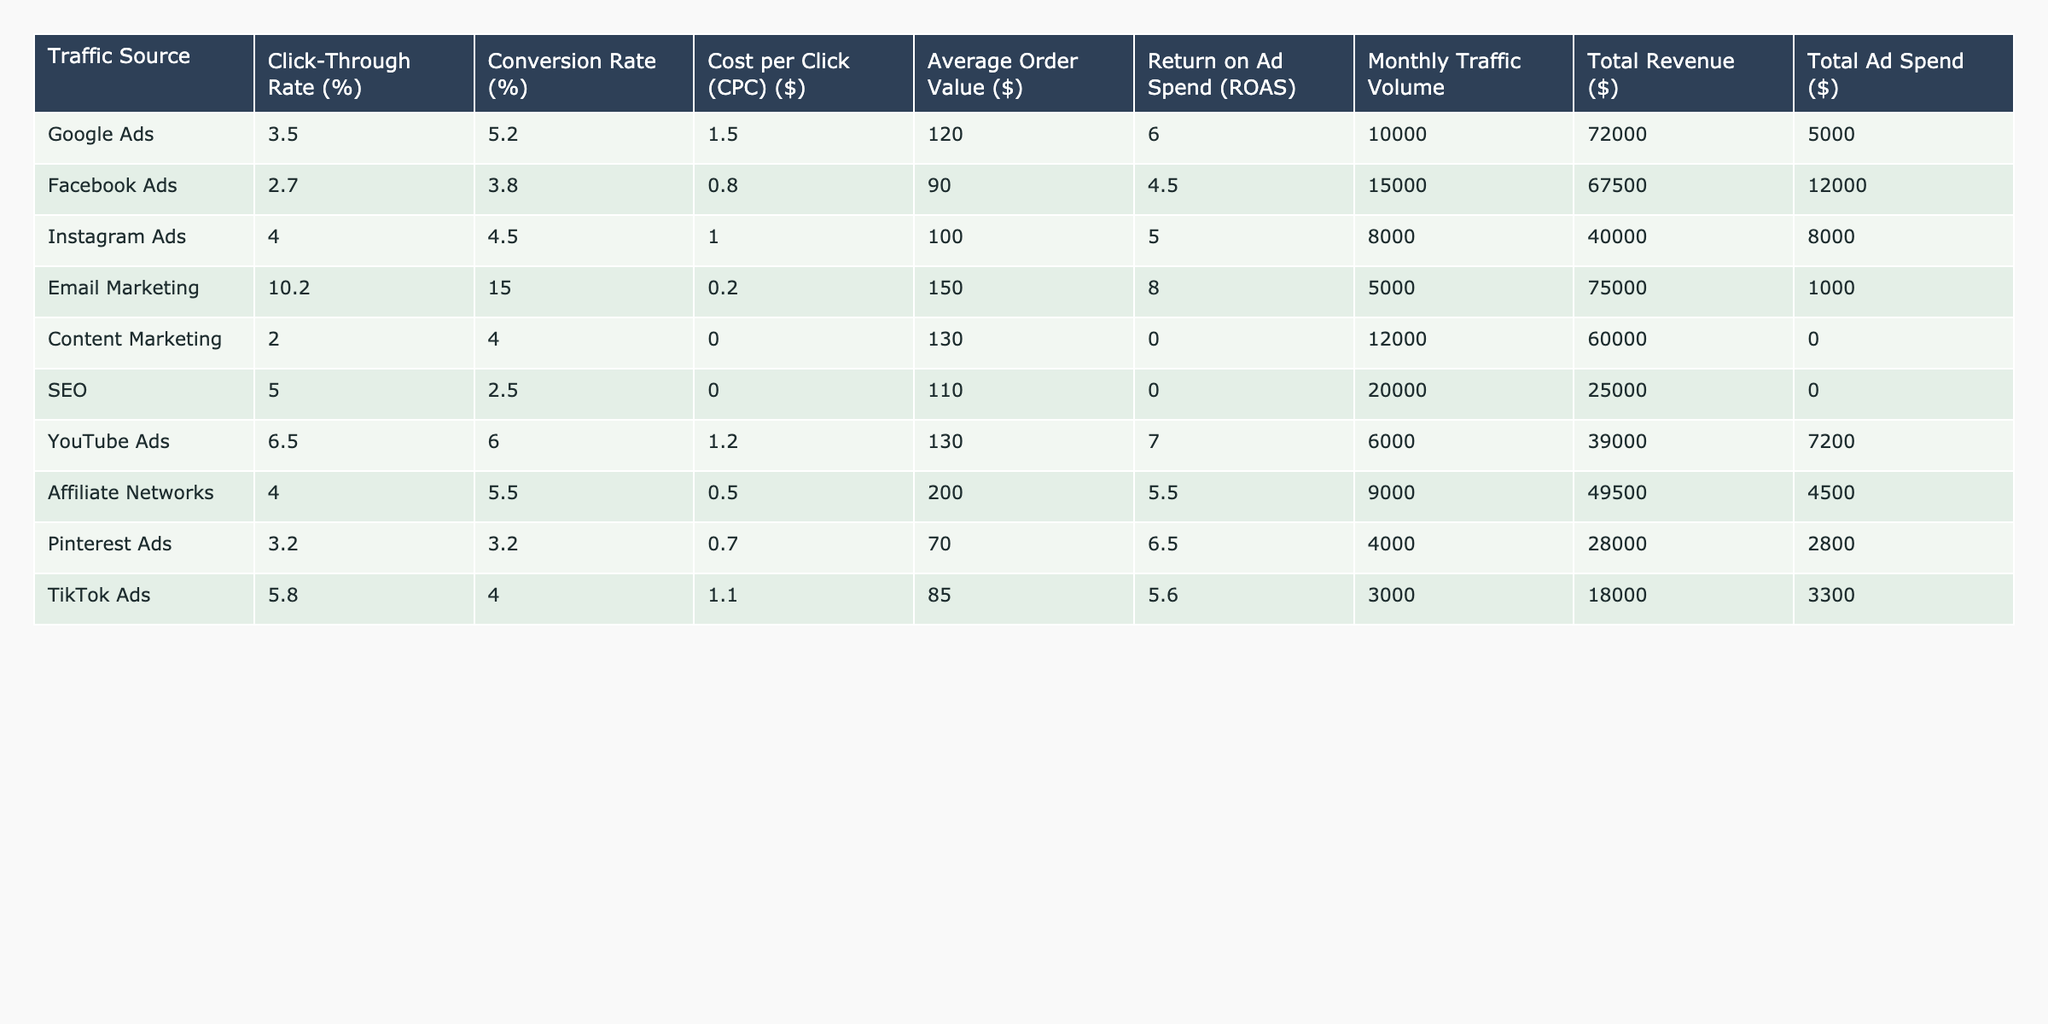What's the Click-Through Rate for Google Ads? The table shows that the Click-Through Rate for Google Ads is listed as 3.5%.
Answer: 3.5% Which traffic source has the highest conversion rate? By examining the table, Email Marketing has the highest conversion rate at 15.0%.
Answer: Email Marketing What is the average Cost per Click (CPC) across all traffic sources? To calculate the average CPC, add all CPC values: (1.50 + 0.80 + 1.00 + 0.20 + 0.00 + 0.00 + 1.20 + 0.50 + 0.70 + 1.10 = 7.10), then divide by the number of traffic sources (10): 7.10 / 10 = 0.71.
Answer: 0.71 Is the Return on Ad Spend (ROAS) for Facebook Ads greater than 5.0? The ROAS for Facebook Ads is 4.5, which is less than 5.0, so the statement is false.
Answer: False What is the total revenue from all traffic sources? By summing all total revenue values: (72000 + 67500 + 40000 + 75000 + 60000 + 25000 + 39000 + 49500 + 28000 + 18000 = 397000).
Answer: 397000 Which traffic source has the lowest Monthly Traffic Volume? Looking at the Monthly Traffic Volume column, TikTok Ads has the lowest at 3000.
Answer: TikTok Ads What is the difference in Average Order Value (AOV) between Email Marketing and Instagram Ads? The AOV for Email Marketing is 150.00 and for Instagram Ads is 100.00. The difference is 150.00 - 100.00 = 50.00.
Answer: 50.00 Are the Total Ad Spend and Total Revenue for SEO both zero? Total Ad Spend for SEO is zero, but Total Revenue is 25000, so the statement is false.
Answer: False What is the highest Return on Ad Spend (ROAS) among all traffic sources? After examining the ROAS values, Email Marketing at 8.0 has the highest ROAS.
Answer: 8.0 What is the average Click-Through Rate (CTR) for all traffic sources? To find the average CTR, sum the Click-Through Rates: (3.5 + 2.7 + 4.0 + 10.2 + 2.0 + 5.0 + 6.5 + 4.0 + 3.2 + 5.8 = 43.9), then divide by the number of sources (10): 43.9 / 10 = 4.39.
Answer: 4.39 